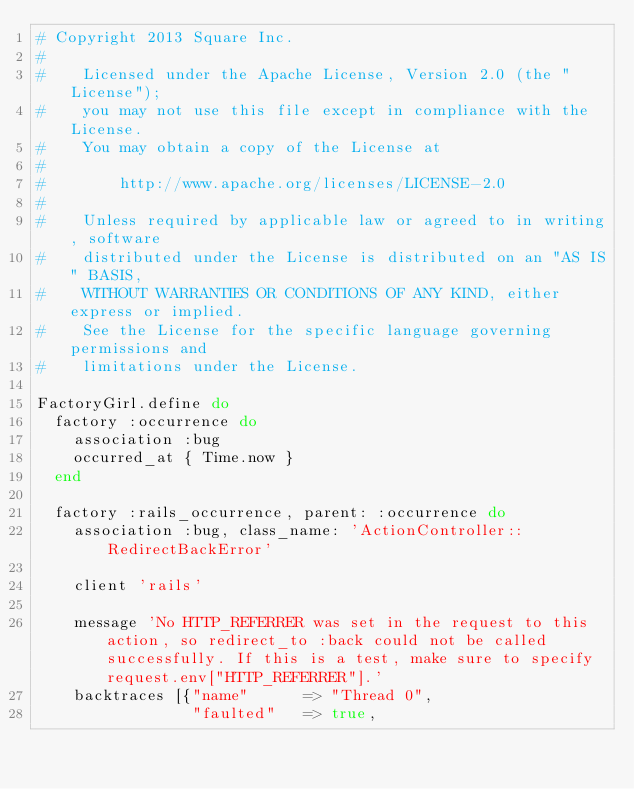<code> <loc_0><loc_0><loc_500><loc_500><_Ruby_># Copyright 2013 Square Inc.
#
#    Licensed under the Apache License, Version 2.0 (the "License");
#    you may not use this file except in compliance with the License.
#    You may obtain a copy of the License at
#
#        http://www.apache.org/licenses/LICENSE-2.0
#
#    Unless required by applicable law or agreed to in writing, software
#    distributed under the License is distributed on an "AS IS" BASIS,
#    WITHOUT WARRANTIES OR CONDITIONS OF ANY KIND, either express or implied.
#    See the License for the specific language governing permissions and
#    limitations under the License.

FactoryGirl.define do
  factory :occurrence do
    association :bug
    occurred_at { Time.now }
  end

  factory :rails_occurrence, parent: :occurrence do
    association :bug, class_name: 'ActionController::RedirectBackError'

    client 'rails'

    message 'No HTTP_REFERRER was set in the request to this action, so redirect_to :back could not be called successfully. If this is a test, make sure to specify request.env["HTTP_REFERRER"].'
    backtraces [{"name"      => "Thread 0",
                 "faulted"   => true,</code> 